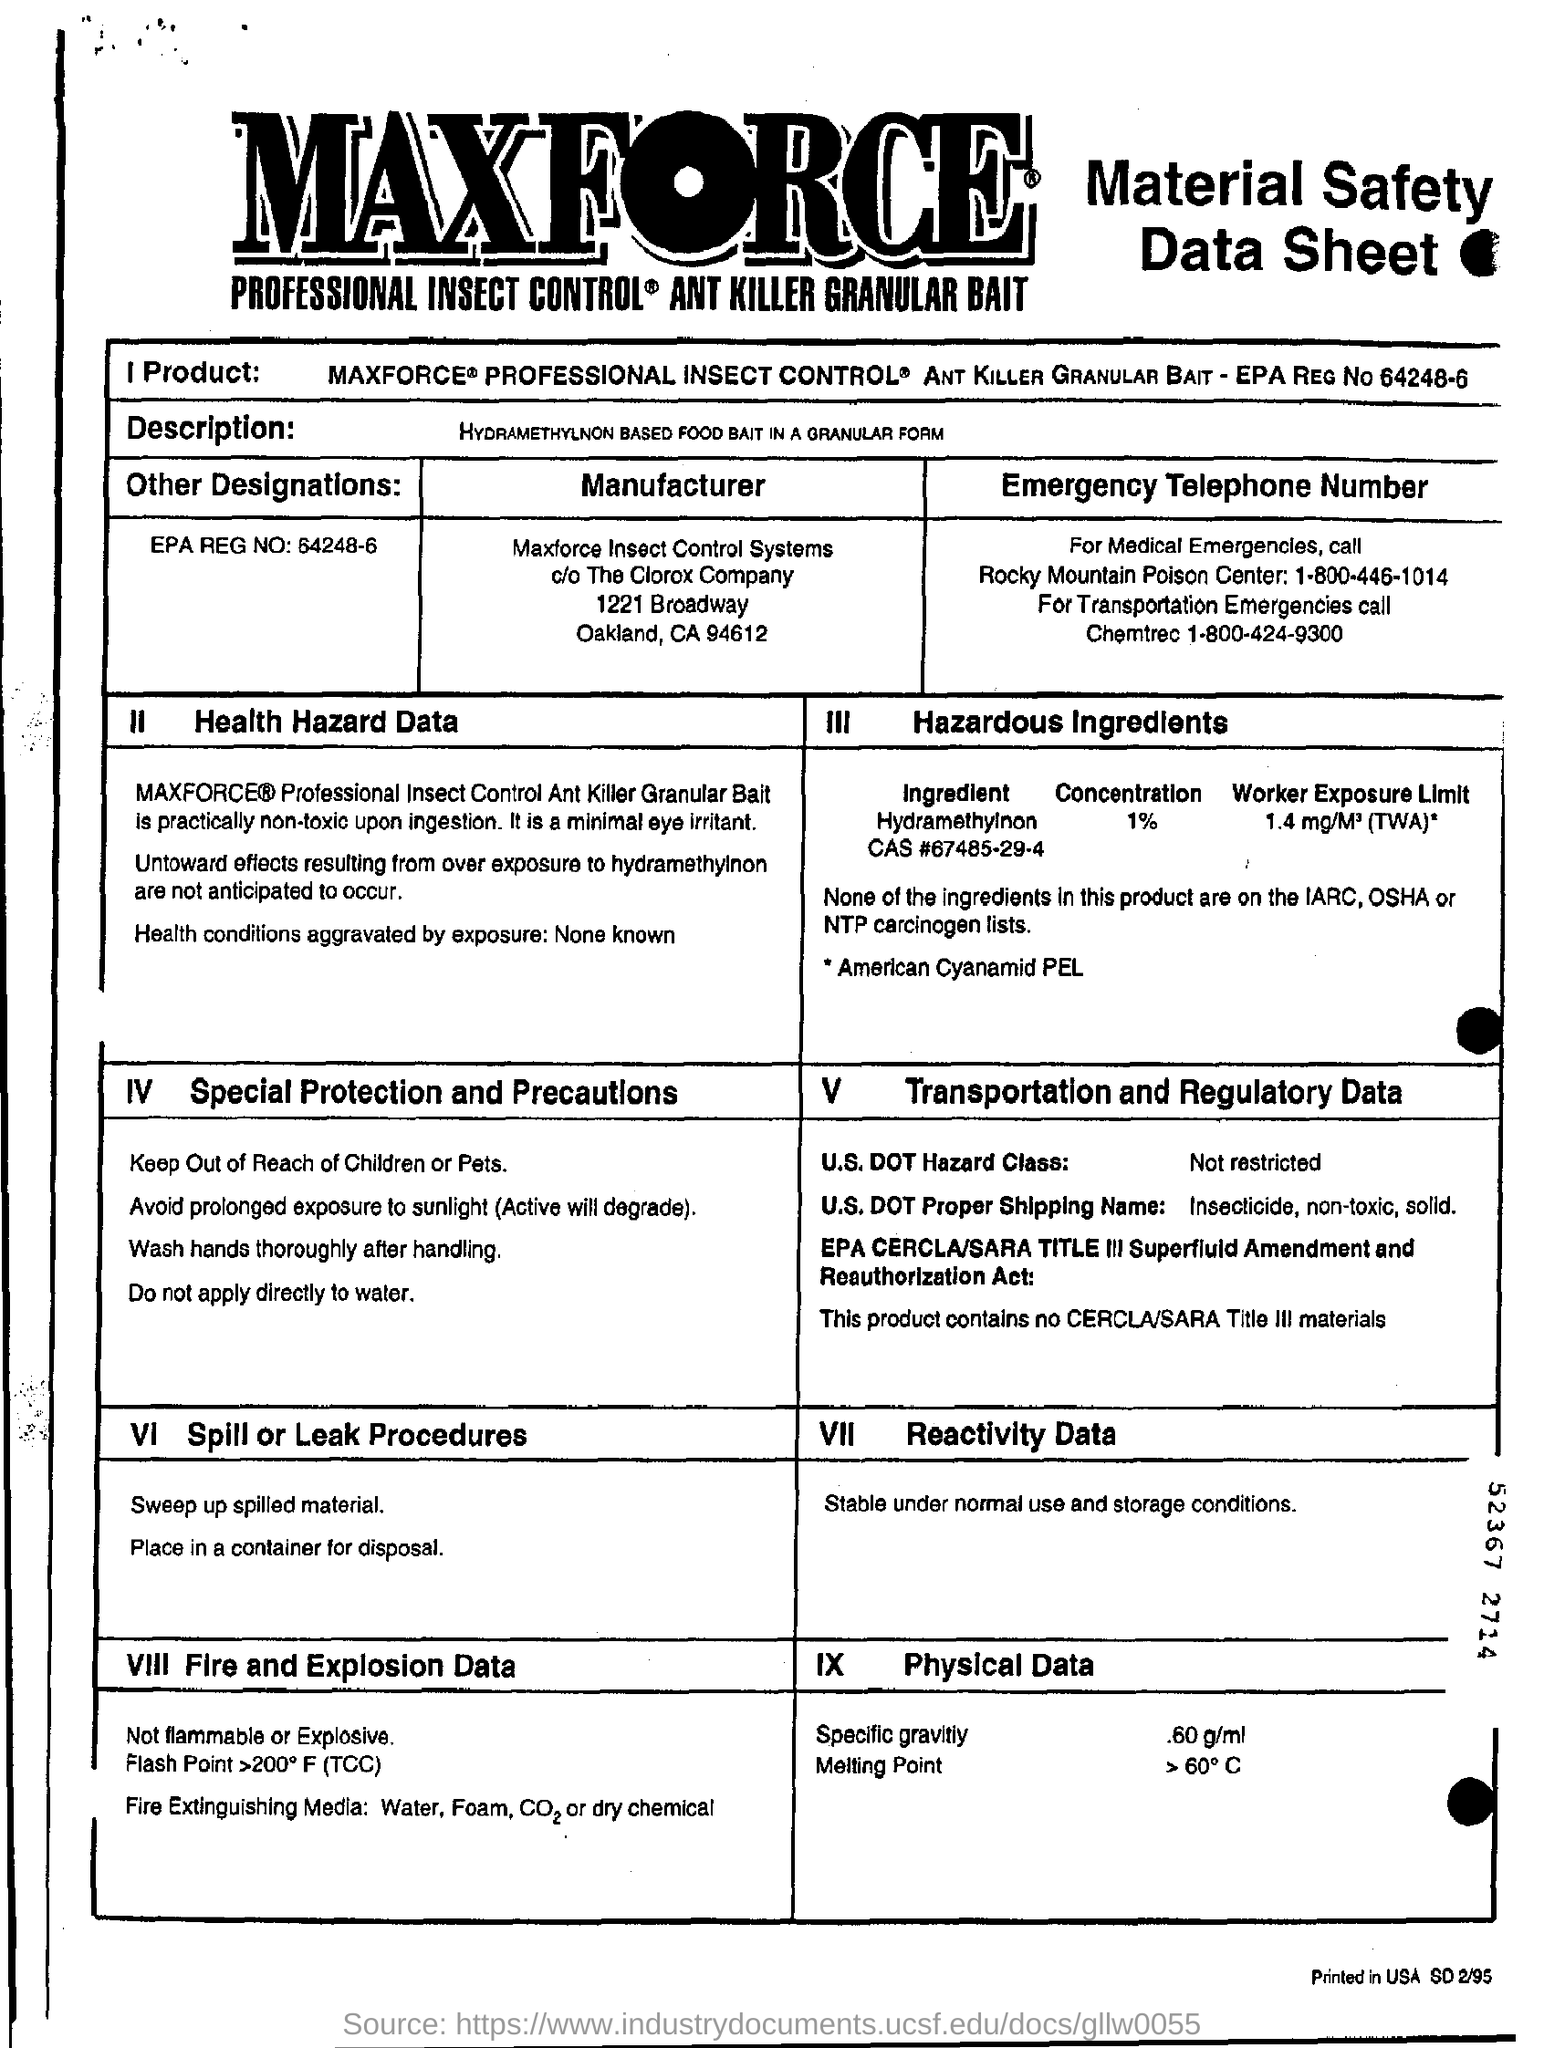What is given in "Other Designations"?
Ensure brevity in your answer.  EPA REG NO: 54248-6. What is the "Physical Data" for "Specific Gravity?
Make the answer very short. .60 g/ml. What is the U.S. DOT Hazard Class?
Keep it short and to the point. Not restricted. What is  "U.S. DOT Proper Shipping Name" given in section V?
Ensure brevity in your answer.  Insecticide, non-toxic, solid. 